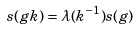<formula> <loc_0><loc_0><loc_500><loc_500>s ( g k ) = \lambda ( k ^ { - 1 } ) s ( g )</formula> 